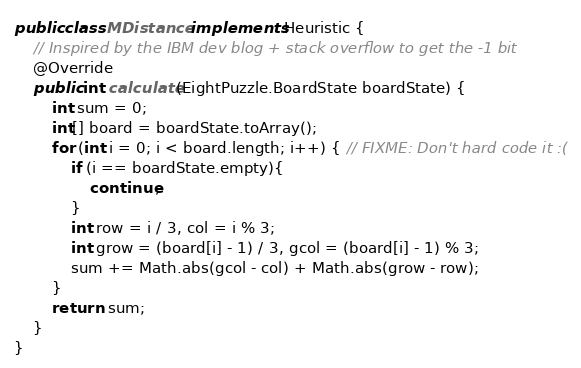Convert code to text. <code><loc_0><loc_0><loc_500><loc_500><_Java_>public class MDistance implements Heuristic {
    // Inspired by the IBM dev blog + stack overflow to get the -1 bit
    @Override
    public int calculate(EightPuzzle.BoardState boardState) {
        int sum = 0;
        int[] board = boardState.toArray();
        for (int i = 0; i < board.length; i++) { // FIXME: Don't hard code it :(
            if (i == boardState.empty){
                continue;
            }
            int row = i / 3, col = i % 3;
            int grow = (board[i] - 1) / 3, gcol = (board[i] - 1) % 3;
            sum += Math.abs(gcol - col) + Math.abs(grow - row);
        }
        return  sum;
    }
}
</code> 